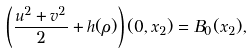Convert formula to latex. <formula><loc_0><loc_0><loc_500><loc_500>\left ( \frac { u ^ { 2 } + v ^ { 2 } } { 2 } + h ( \rho ) \right ) ( 0 , x _ { 2 } ) = B _ { 0 } ( x _ { 2 } ) ,</formula> 